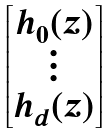<formula> <loc_0><loc_0><loc_500><loc_500>\begin{bmatrix} h _ { 0 } ( z ) \\ \vdots \\ h _ { d } ( z ) \end{bmatrix}</formula> 